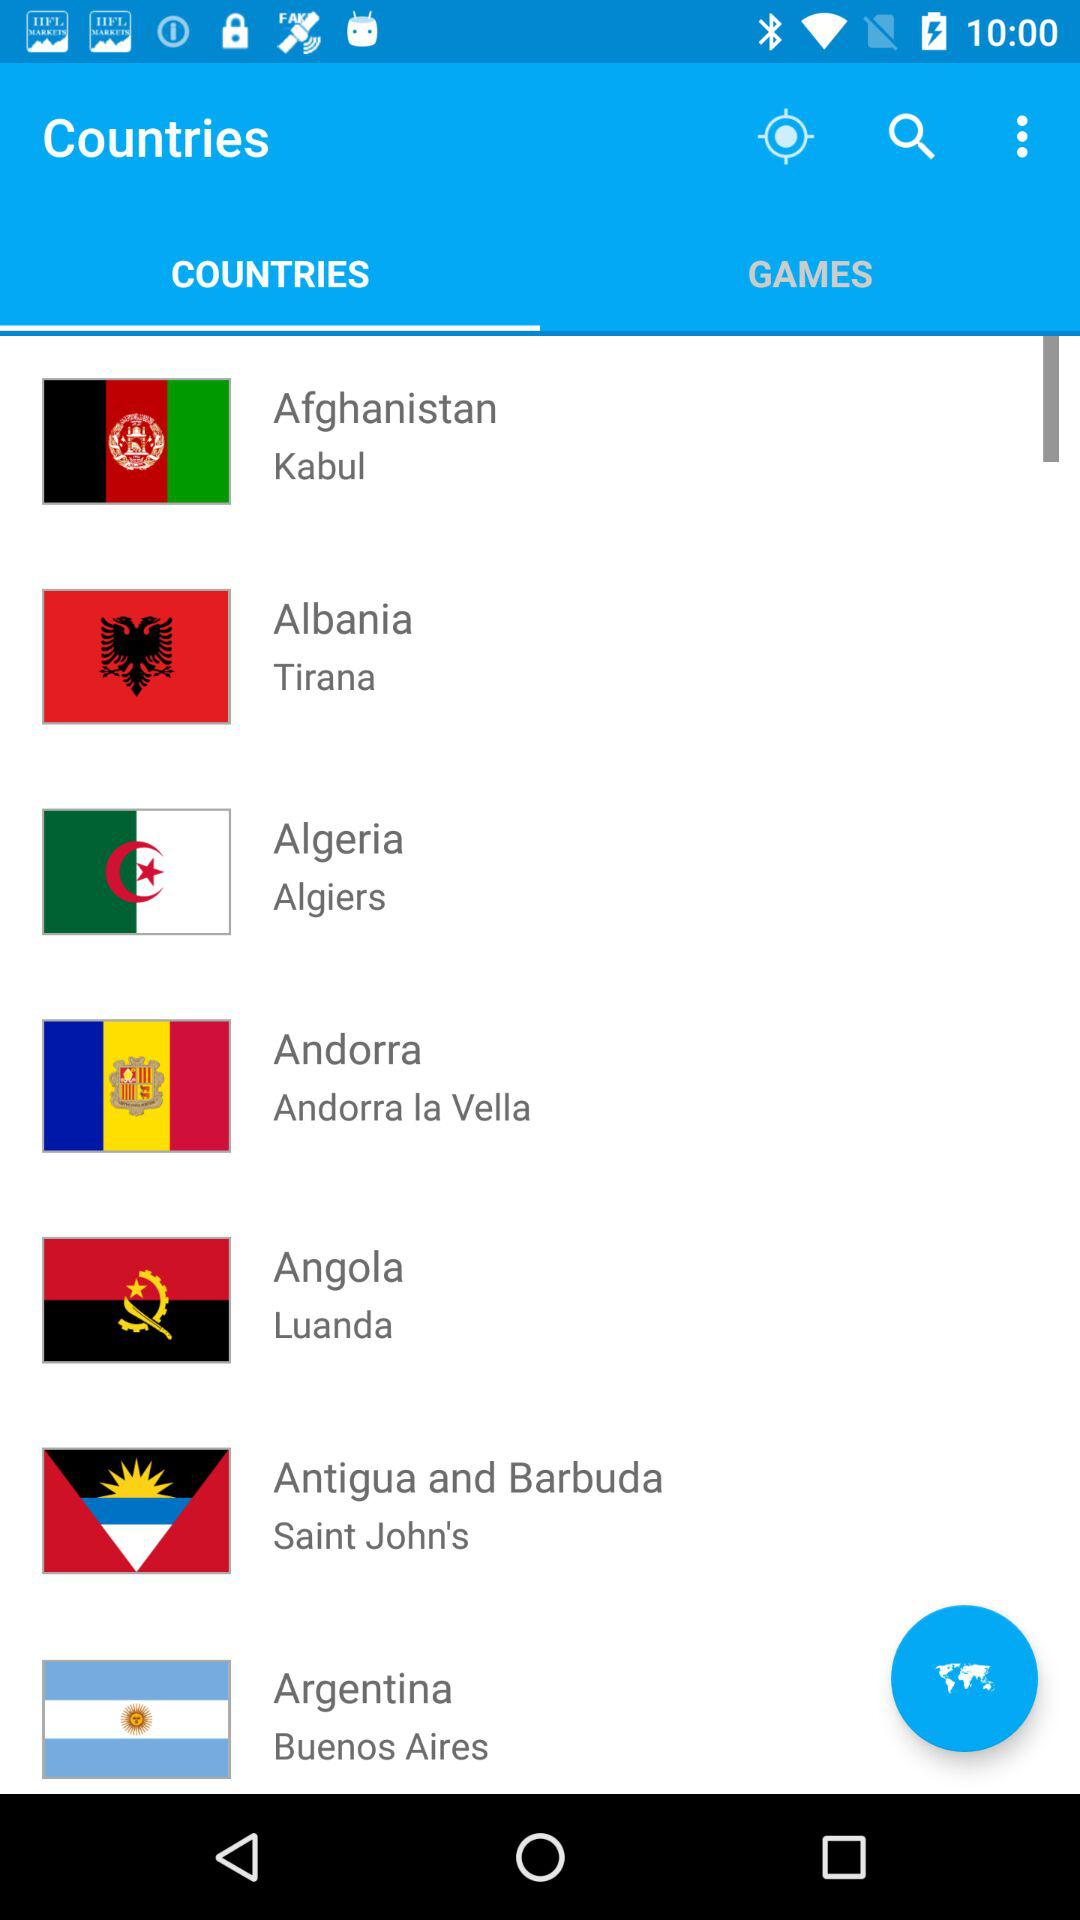Which country has the capital of Algiers? The country is Algeria. 